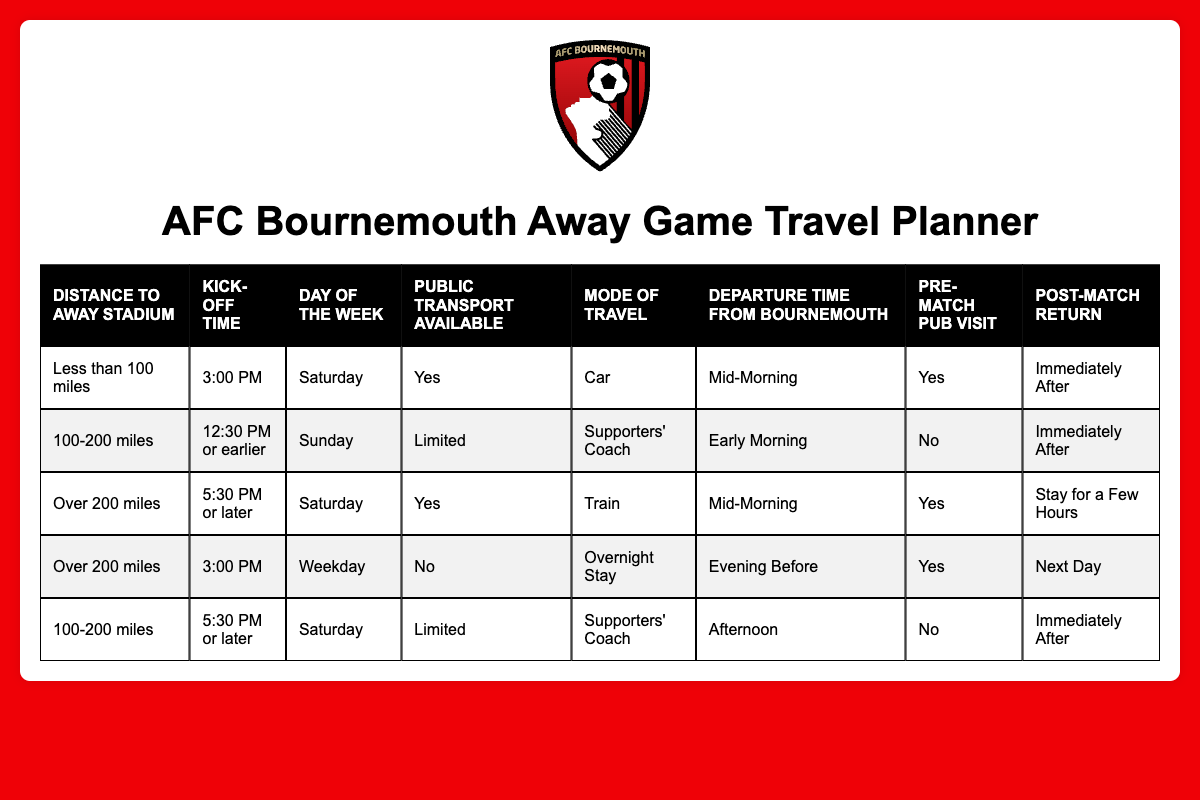What mode of travel is suggested for a game more than 200 miles away with a kick-off time of 5:30 PM or later on a Saturday? Looking at the table, there is a rule for "Over 200 miles" with "5:30 PM or later" on "Saturday". It indicates that the suggested mode of travel is "Train".
Answer: Train What is the recommended departure time for a match that is less than 100 miles away with a kick-off at 3:00 PM on a Saturday? From the table, the corresponding entry for "Less than 100 miles", "3:00 PM", and "Saturday" shows the recommended departure time to be "Mid-Morning".
Answer: Mid-Morning Is public transport available for the match that is over 200 miles away, has a kick-off time of 3:00 PM, and falls on a weekday? By examining the table, for "Over 200 miles", "3:00 PM", and "Weekday", the entry states "No" for public transport availability.
Answer: No What is the total number of travel modes suggested for matches scheduled on Saturdays? To find this, I’ll look through each row with "Saturday". The suggested travel modes for entries are "Car", "Supporters' Coach", and "Supporters' Coach" again, giving us three distinct travel modes.
Answer: 3 Are there any matches listed with a pre-match pub visit recommendation of 'Yes' that also involve a train for travel? Checking the table, there is one entry for "Over 200 miles", "5:30 PM or later", "Saturday", with "Yes" for pre-match pub visit, and the mode of travel is "Train". Thus, there is a match that fulfills these conditions.
Answer: Yes What is the post-match return suggestion for travelling by supporters' coach for a match that is 100-200 miles away, kicks off after 5:30 PM on a Saturday? From the table, the only relevant entry is for "100-200 miles", "5:30 PM or later", "Saturday", which suggests a post-match return of "Immediately After".
Answer: Immediately After Which distance category requires an overnight stay when the kick-off is at 3:00 PM on a weekday? In the table, checking for "3:00 PM" and "Weekday", the matching distance category is "Over 200 miles", which requires an "Overnight Stay".
Answer: Over 200 miles What is the departure time from Bournemouth suggested for matches that are 100-200 miles away and occur on Sundays? Reviewing the table, for matches that are "100-200 miles", "12:30 PM or earlier", and "Sunday", the suggested departure time is "Early Morning".
Answer: Early Morning How many matches suggest a 'No' for pre-match pub visits? From the table, two matches indicate "No" for pre-match pub visits, those involving "100-200 miles" on Sunday and "100-200 miles" kicking off after 5:30 PM, yielding a count of two.
Answer: 2 